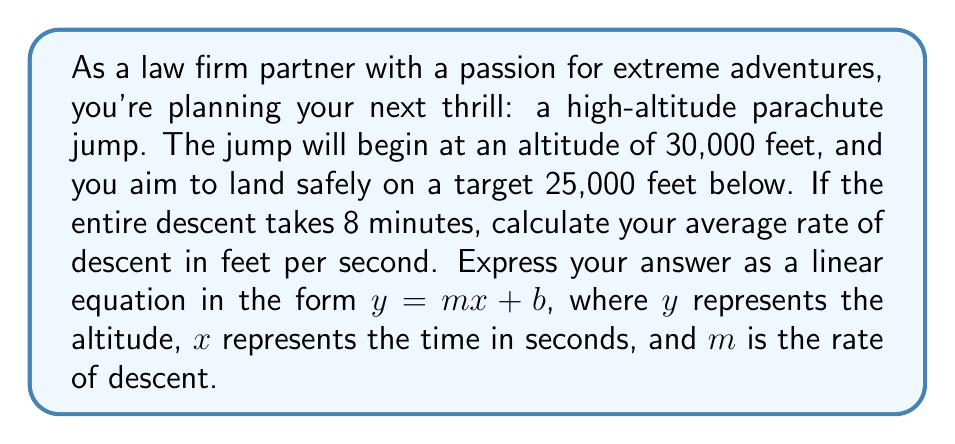Solve this math problem. To solve this problem, we'll follow these steps:

1. Identify the given information:
   - Starting altitude: 30,000 feet
   - Landing altitude: 30,000 - 25,000 = 5,000 feet
   - Total descent time: 8 minutes = 8 × 60 = 480 seconds

2. Calculate the total distance traveled:
   $\text{Distance} = 30,000 - 5,000 = 25,000 \text{ feet}$

3. Calculate the average rate of descent:
   $$\text{Rate} = \frac{\text{Distance}}{\text{Time}} = \frac{25,000 \text{ feet}}{480 \text{ seconds}} = 52.0833... \text{ feet/second}$$

4. Formulate the linear equation:
   - The rate of descent is negative since altitude decreases over time
   - The y-intercept is the starting altitude (30,000 feet)
   
   $$y = -52.0833x + 30000$$

   Where:
   - $y$ is the altitude in feet
   - $x$ is the time in seconds
   - $-52.0833$ is the rate of descent in feet per second
   - $30000$ is the starting altitude in feet
Answer: $y = -52.0833x + 30000$ 